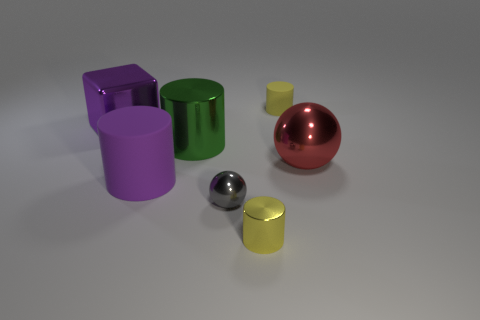How would you describe the composition of objects in the image? The image depicts a collection of geometric solids with a glossy finish. There is a variety of colors and shapes, including a green cylinder, a purple cube, and a red sphere, all resting on what appears to be a smooth surface under even lighting. 